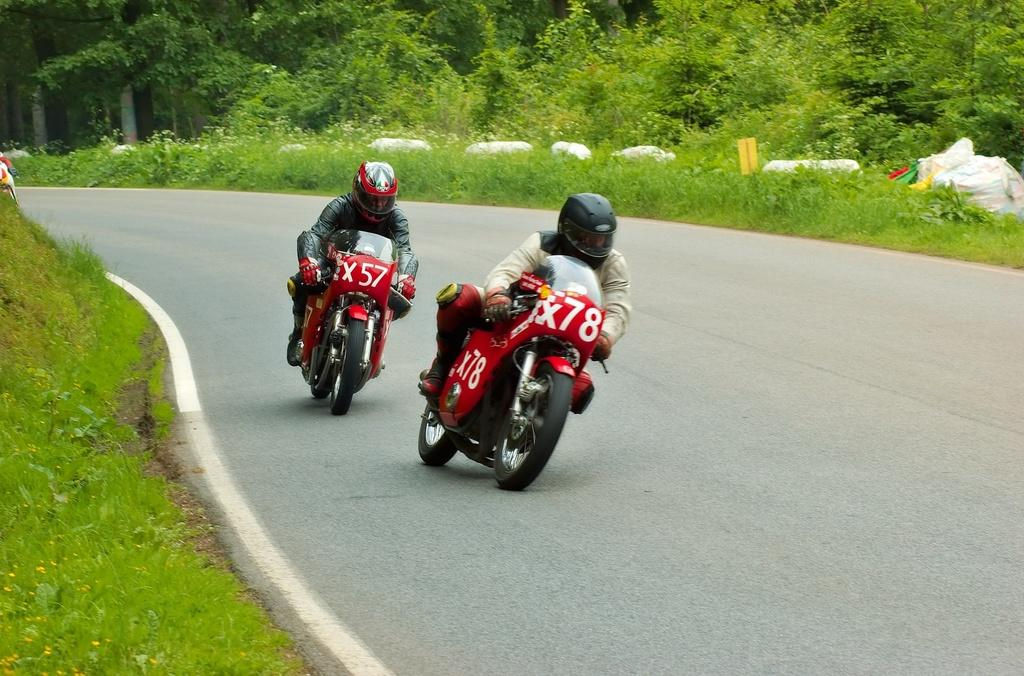What are the people in the image doing? There are two people driving bikes in the image. What safety precautions are the people taking while riding their bikes? The people are wearing helmets. What color are the bikes in the image? The bikes are red. What can be seen on either side of the road in the image? There are plants and trees on either side of the road in the image. What type of brush is being used to paint the bit in the image? There is no brush or bit present in the image; it features two people riding red bikes with plants and trees on either side of the road. 